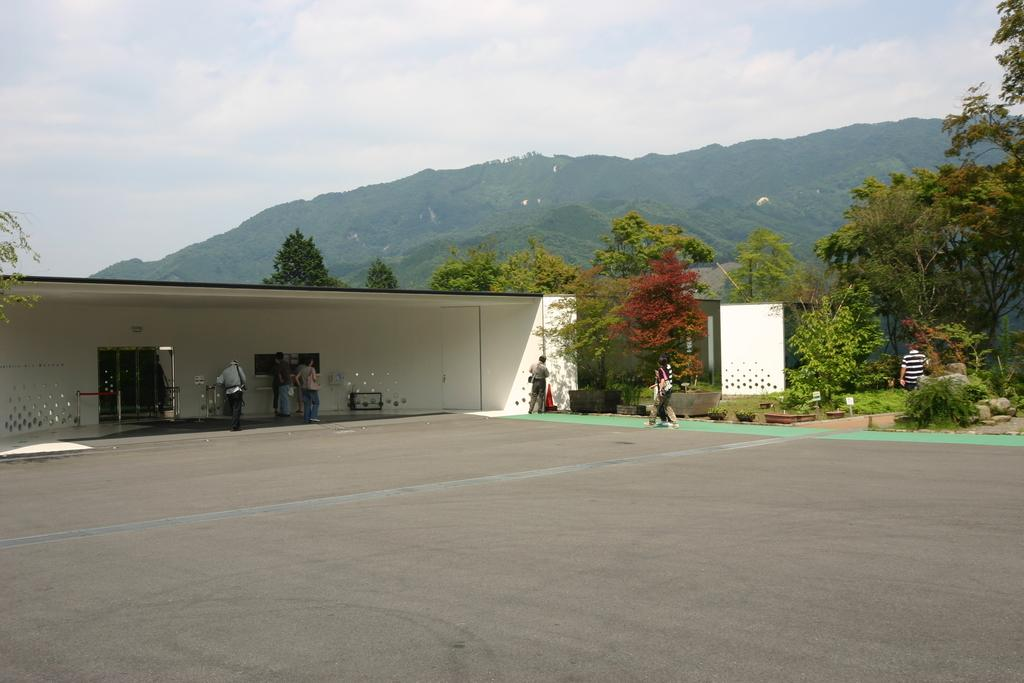What is the main feature of the image? There is a road in the image. What are the people in the image doing? There are people standing and walking in the image. What type of vegetation can be seen in the image? There are shrubs and trees in the image. What type of terrain is visible in the image? There are hills in the image. What is visible in the background of the image? The sky is visible in the image, and clouds are present in the sky. What type of drink is being served at the school in the image? There is no school or drink present in the image. 